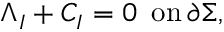<formula> <loc_0><loc_0><loc_500><loc_500>\Lambda _ { I } + C _ { I } = 0 \, o n \, \partial \Sigma ,</formula> 